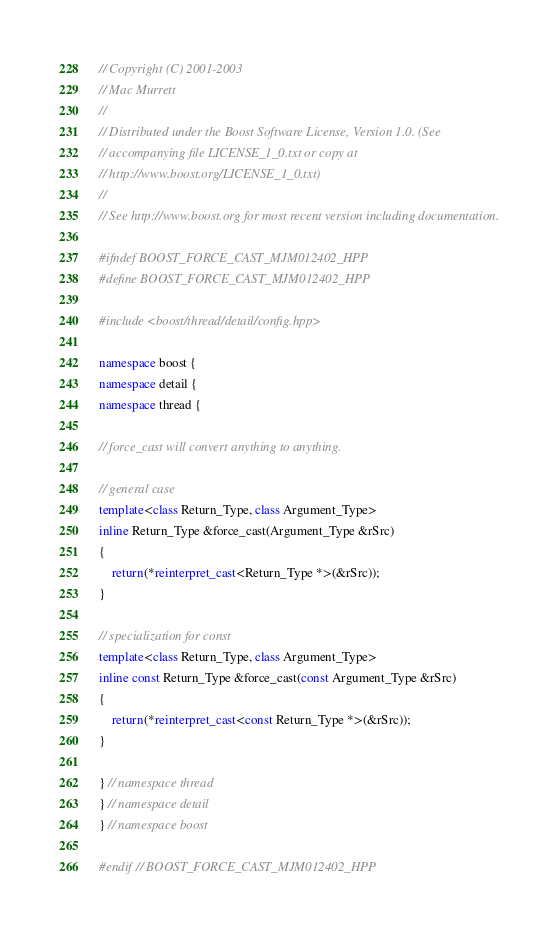Convert code to text. <code><loc_0><loc_0><loc_500><loc_500><_C++_>// Copyright (C) 2001-2003
// Mac Murrett
//
// Distributed under the Boost Software License, Version 1.0. (See
// accompanying file LICENSE_1_0.txt or copy at
// http://www.boost.org/LICENSE_1_0.txt)
//
// See http://www.boost.org for most recent version including documentation.

#ifndef BOOST_FORCE_CAST_MJM012402_HPP
#define BOOST_FORCE_CAST_MJM012402_HPP

#include <boost/thread/detail/config.hpp>

namespace boost {
namespace detail {
namespace thread {

// force_cast will convert anything to anything.

// general case
template<class Return_Type, class Argument_Type>
inline Return_Type &force_cast(Argument_Type &rSrc)
{
    return(*reinterpret_cast<Return_Type *>(&rSrc));
}

// specialization for const
template<class Return_Type, class Argument_Type>
inline const Return_Type &force_cast(const Argument_Type &rSrc)
{
    return(*reinterpret_cast<const Return_Type *>(&rSrc));
}

} // namespace thread
} // namespace detail
} // namespace boost

#endif // BOOST_FORCE_CAST_MJM012402_HPP
</code> 